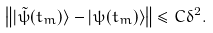<formula> <loc_0><loc_0><loc_500><loc_500>\left \| | \tilde { \psi } ( t _ { m } ) \rangle - | \psi ( t _ { m } ) \rangle \right \| \leq C \delta ^ { 2 } .</formula> 